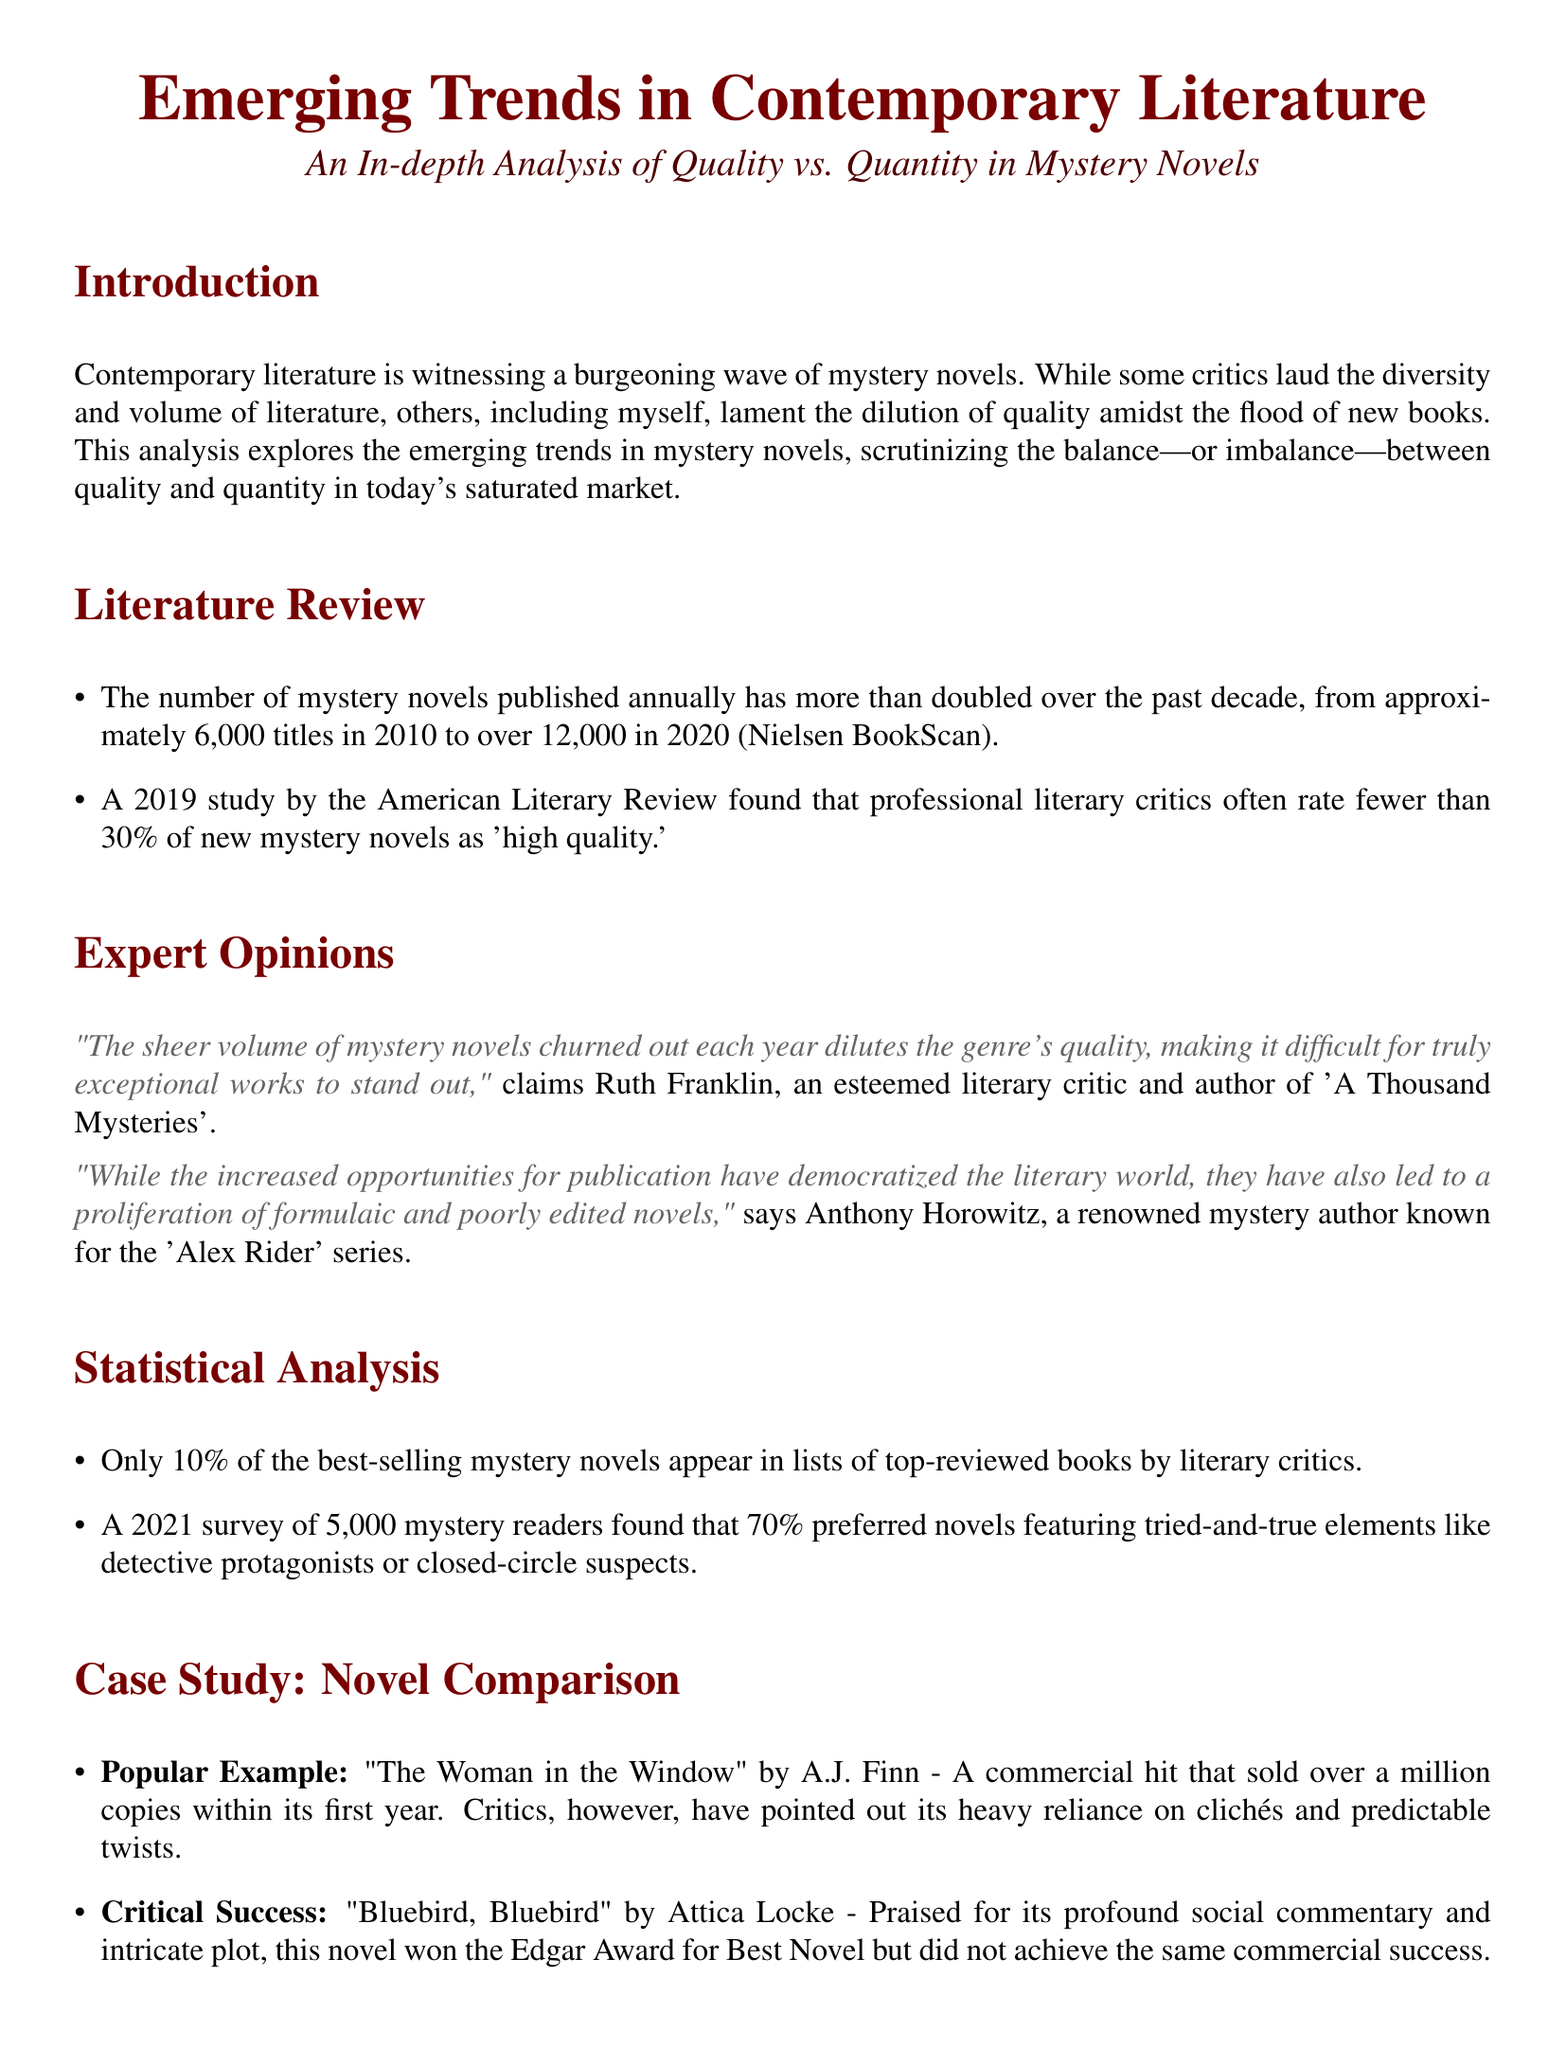What was the number of mystery novels published in 2010? The document states that approximately 6,000 titles were published in 2010.
Answer: 6,000 What percentage of new mystery novels are rated as 'high quality' by critics? A 2019 study found that fewer than 30% of new mystery novels are rated as 'high quality.'
Answer: 30% Which novel is cited as a commercial hit? The document mentions "The Woman in the Window" by A.J. Finn as a commercial hit.
Answer: "The Woman in the Window" Who authored 'A Thousand Mysteries'? Ruth Franklin is the author of 'A Thousand Mysteries.'
Answer: Ruth Franklin What percentage of readers preferred novels with tried-and-true elements? The 2021 survey indicated that 70% of readers preferred these novels.
Answer: 70% What is the title of the critical success mentioned in the case study? "Bluebird, Bluebird" by Attica Locke is the title mentioned.
Answer: "Bluebird, Bluebird" What literary award did "Bluebird, Bluebird" win? The document states that the novel won the Edgar Award for Best Novel.
Answer: Edgar Award What is a concern mentioned regarding the mystery genre's proliferation? The document emphasizes the concern about declining quality amidst the proliferation.
Answer: Declining quality What type of analysis does the document provide? The document provides an in-depth analysis of quality vs. quantity in mystery novels.
Answer: In-depth analysis 